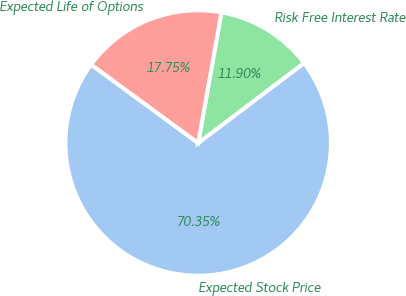Convert chart to OTSL. <chart><loc_0><loc_0><loc_500><loc_500><pie_chart><fcel>Expected Stock Price<fcel>Risk Free Interest Rate<fcel>Expected Life of Options<nl><fcel>70.35%<fcel>11.9%<fcel>17.75%<nl></chart> 